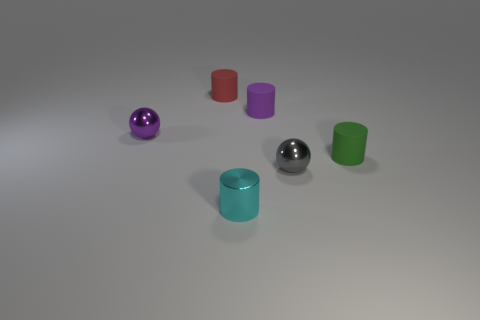There is a small purple object that is made of the same material as the small cyan thing; what shape is it? sphere 